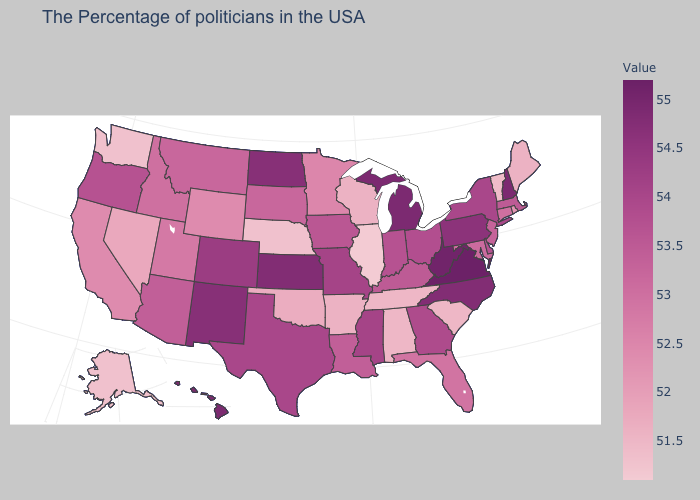Does the map have missing data?
Concise answer only. No. Is the legend a continuous bar?
Give a very brief answer. Yes. Among the states that border Texas , which have the lowest value?
Write a very short answer. Arkansas. Among the states that border Idaho , does Washington have the lowest value?
Short answer required. Yes. Does South Dakota have a higher value than Oklahoma?
Concise answer only. Yes. Does Delaware have a higher value than Arkansas?
Give a very brief answer. Yes. Among the states that border Ohio , which have the lowest value?
Write a very short answer. Kentucky. Which states have the highest value in the USA?
Answer briefly. Virginia. 